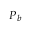Convert formula to latex. <formula><loc_0><loc_0><loc_500><loc_500>P _ { b }</formula> 